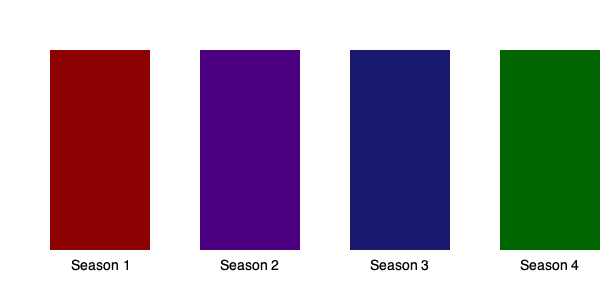How does the color palette evolve across the seasons of The Handmaid's Tale, and what might this progression symbolize in terms of the story's themes and character development? 1. Season 1 (Dark Red - #8B0000):
   - Represents blood, oppression, and the Handmaids' iconic red robes.
   - Symbolizes the intense, visceral nature of the newly established Gilead regime.

2. Season 2 (Indigo - #4B0082):
   - Shifts towards a darker, more mysterious tone.
   - Indicates deepening complexities and hidden resistances forming.

3. Season 3 (Midnight Blue - #191970):
   - Moves to a cooler, deeper blue.
   - Suggests a sense of hope emerging, but still shrouded in darkness.

4. Season 4 (Dark Green - #006400):
   - Introduces a new color entirely, signifying growth and change.
   - Represents hope, renewal, and the possibility of freedom.

The color progression from warm (red) to cool (blue) and finally to green symbolizes:
   a) The gradual shift from immediate trauma to strategic resistance.
   b) Characters' emotional journeys from fear and anger to hope and determination.
   c) The expanding scope of the story beyond Gilead's borders.

This evolution aligns with the series' thematic development, reflecting the characters' growth, particularly June's (played by Elisabeth Moss) transformation from a victim to a leader in the resistance.
Answer: From oppression (red) to hope (green), mirroring character growth and expanding storylines. 